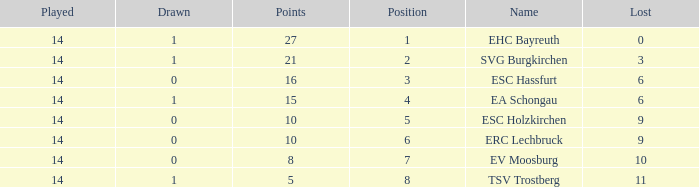What's the most points for Ea Schongau with more than 1 drawn? None. 